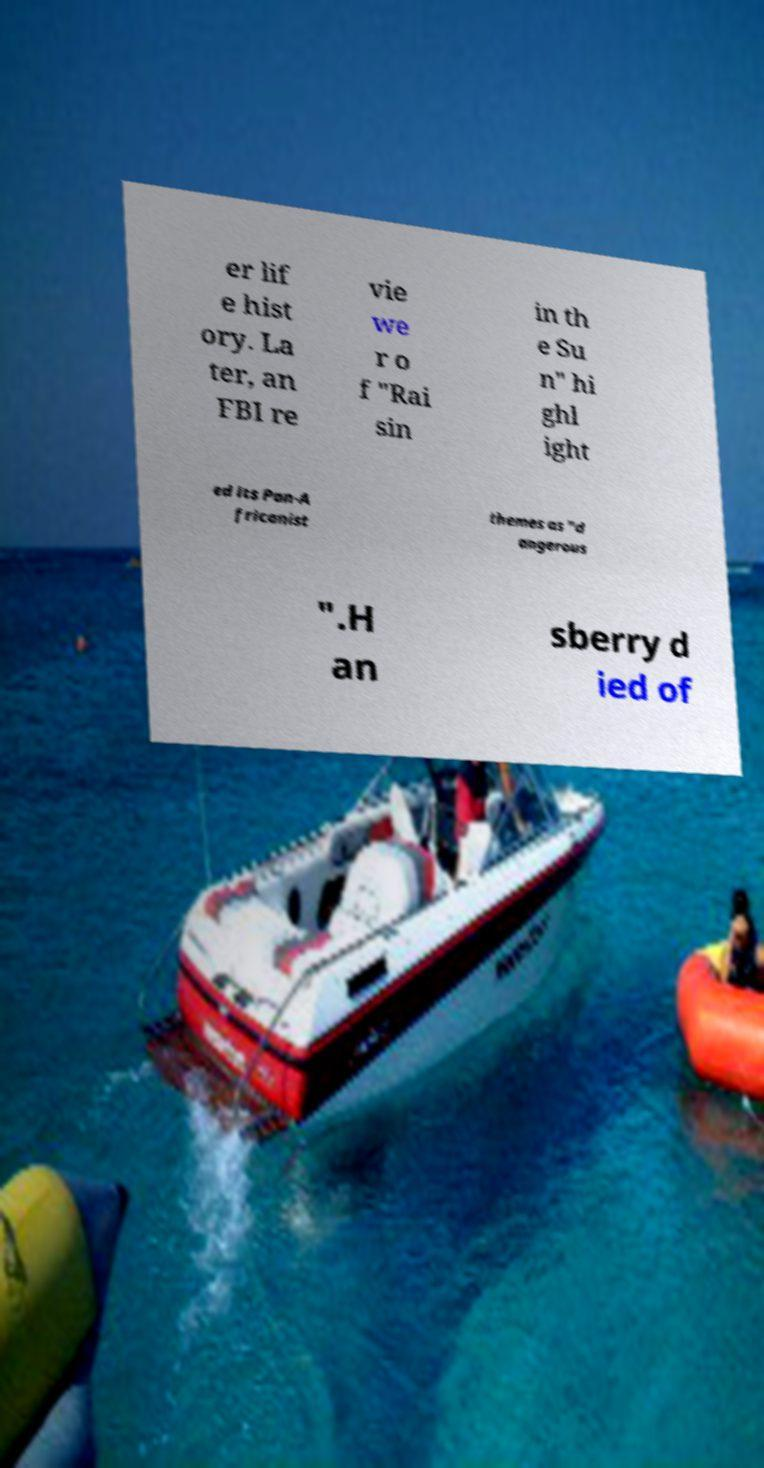Can you accurately transcribe the text from the provided image for me? er lif e hist ory. La ter, an FBI re vie we r o f "Rai sin in th e Su n" hi ghl ight ed its Pan-A fricanist themes as "d angerous ".H an sberry d ied of 